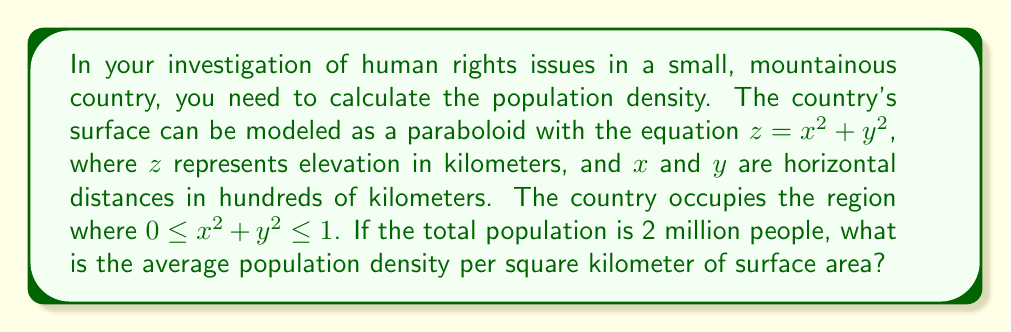Show me your answer to this math problem. To solve this problem, we need to follow these steps:

1. Calculate the surface area of the paraboloid region.
2. Divide the total population by the surface area.

Step 1: Calculating the surface area

The surface area of a paraboloid can be calculated using the formula:

$$ A = \int_0^{2\pi} \int_0^1 \sqrt{1 + 4r^2} \, r \, dr \, d\theta $$

Where $r = \sqrt{x^2 + y^2}$

Let's solve this integral:

$$ A = 2\pi \int_0^1 \sqrt{1 + 4r^2} \, r \, dr $$

$$ = 2\pi \left[ \frac{1}{12} (1 + 4r^2)^{3/2} \right]_0^1 $$

$$ = 2\pi \left[ \frac{1}{12} (5^{3/2} - 1) \right] $$

$$ = \frac{\pi}{6} (5\sqrt{5} - 1) $$

Step 2: Calculating the population density

The surface area we calculated is in units of $(100 \text{ km})^2$. We need to convert this to $\text{km}^2$:

$$ A_{\text{km}^2} = 10000 \cdot \frac{\pi}{6} (5\sqrt{5} - 1) \approx 5795.55 \text{ km}^2 $$

Now, we can calculate the population density:

$$ \text{Density} = \frac{\text{Population}}{\text{Area}} = \frac{2,000,000}{5795.55} \approx 345.09 \text{ people/km}^2 $$
Answer: The average population density is approximately 345 people per square kilometer of surface area. 